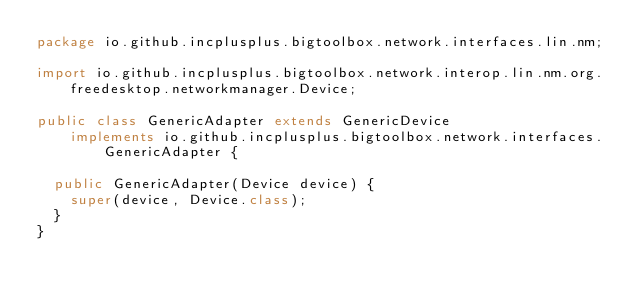<code> <loc_0><loc_0><loc_500><loc_500><_Java_>package io.github.incplusplus.bigtoolbox.network.interfaces.lin.nm;

import io.github.incplusplus.bigtoolbox.network.interop.lin.nm.org.freedesktop.networkmanager.Device;

public class GenericAdapter extends GenericDevice
    implements io.github.incplusplus.bigtoolbox.network.interfaces.GenericAdapter {

  public GenericAdapter(Device device) {
    super(device, Device.class);
  }
}
</code> 